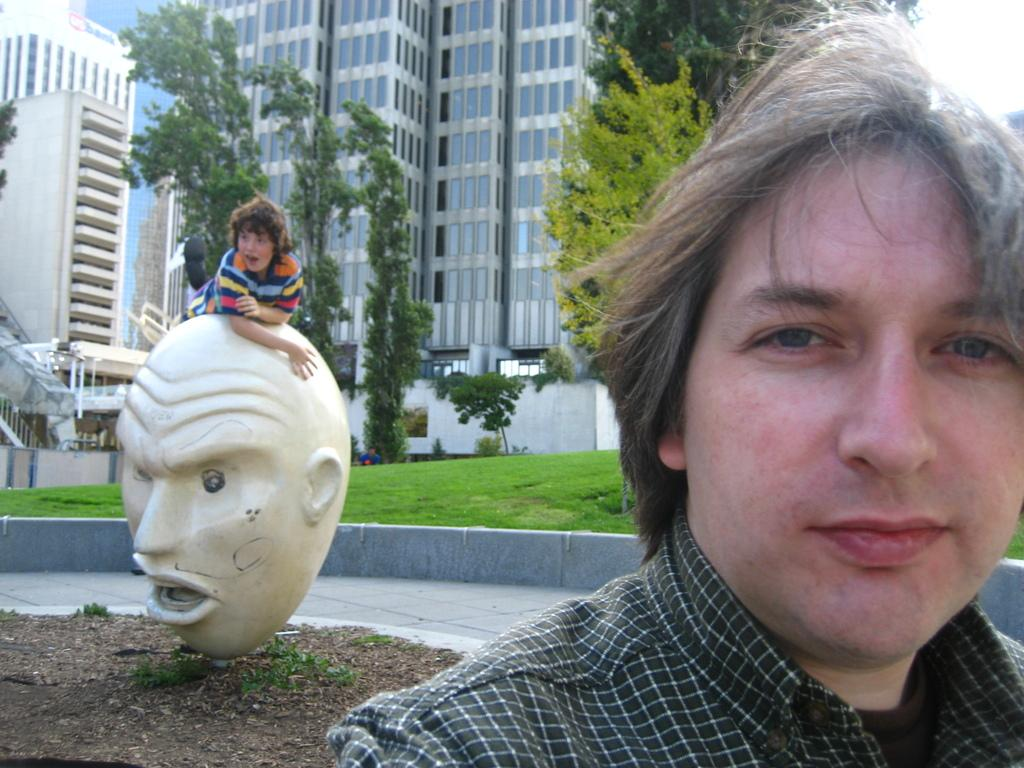What is the main subject in the foreground of the image? There is a person in the foreground of the image. What can be seen in the background of the image? In the background of the image, there is a statue, a boy, sand, grass, trees, plants, buildings, and other objects. Can you describe the statue in the background? Unfortunately, the facts provided do not give any details about the statue, so we cannot describe it. What type of natural environment is visible in the background of the image? The natural environment in the background of the image includes grass, trees, and plants. How many different types of objects are visible in the background of the image? There are at least seven different types of objects visible in the background of the image: a statue, a boy, sand, grass, trees, plants, and buildings. What type of cork can be seen floating in the water in the image? There is no water or cork present in the image. How much does the banana weigh in the image? There is no banana present in the image, so its weight cannot be determined. 